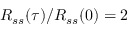<formula> <loc_0><loc_0><loc_500><loc_500>R _ { s s } ( \tau ) / R _ { s s } ( 0 ) = 2</formula> 